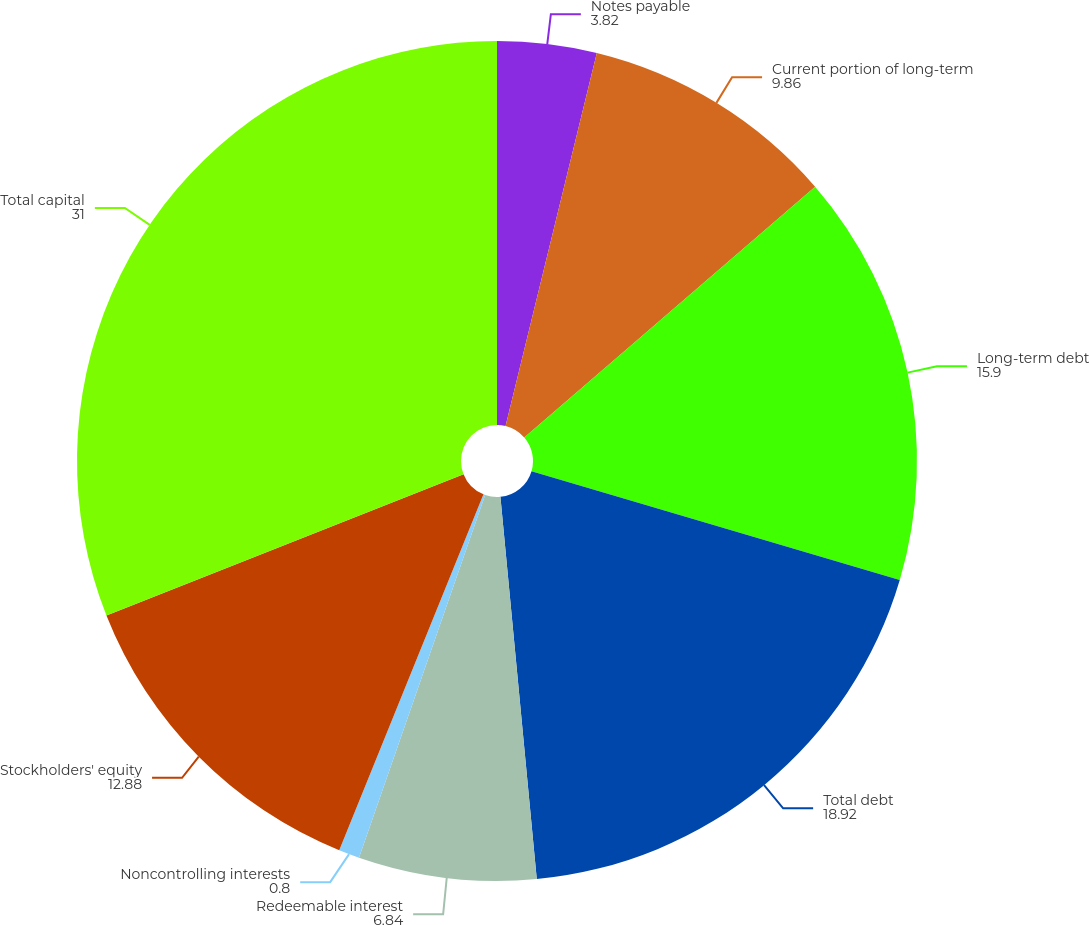Convert chart. <chart><loc_0><loc_0><loc_500><loc_500><pie_chart><fcel>Notes payable<fcel>Current portion of long-term<fcel>Long-term debt<fcel>Total debt<fcel>Redeemable interest<fcel>Noncontrolling interests<fcel>Stockholders' equity<fcel>Total capital<nl><fcel>3.82%<fcel>9.86%<fcel>15.9%<fcel>18.92%<fcel>6.84%<fcel>0.8%<fcel>12.88%<fcel>31.0%<nl></chart> 